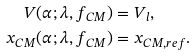<formula> <loc_0><loc_0><loc_500><loc_500>V ( \alpha ; \lambda , f _ { C M } ) & = V _ { l } , \\ x _ { C M } ( \alpha ; \lambda , f _ { C M } ) & = x _ { C M , r e f } .</formula> 